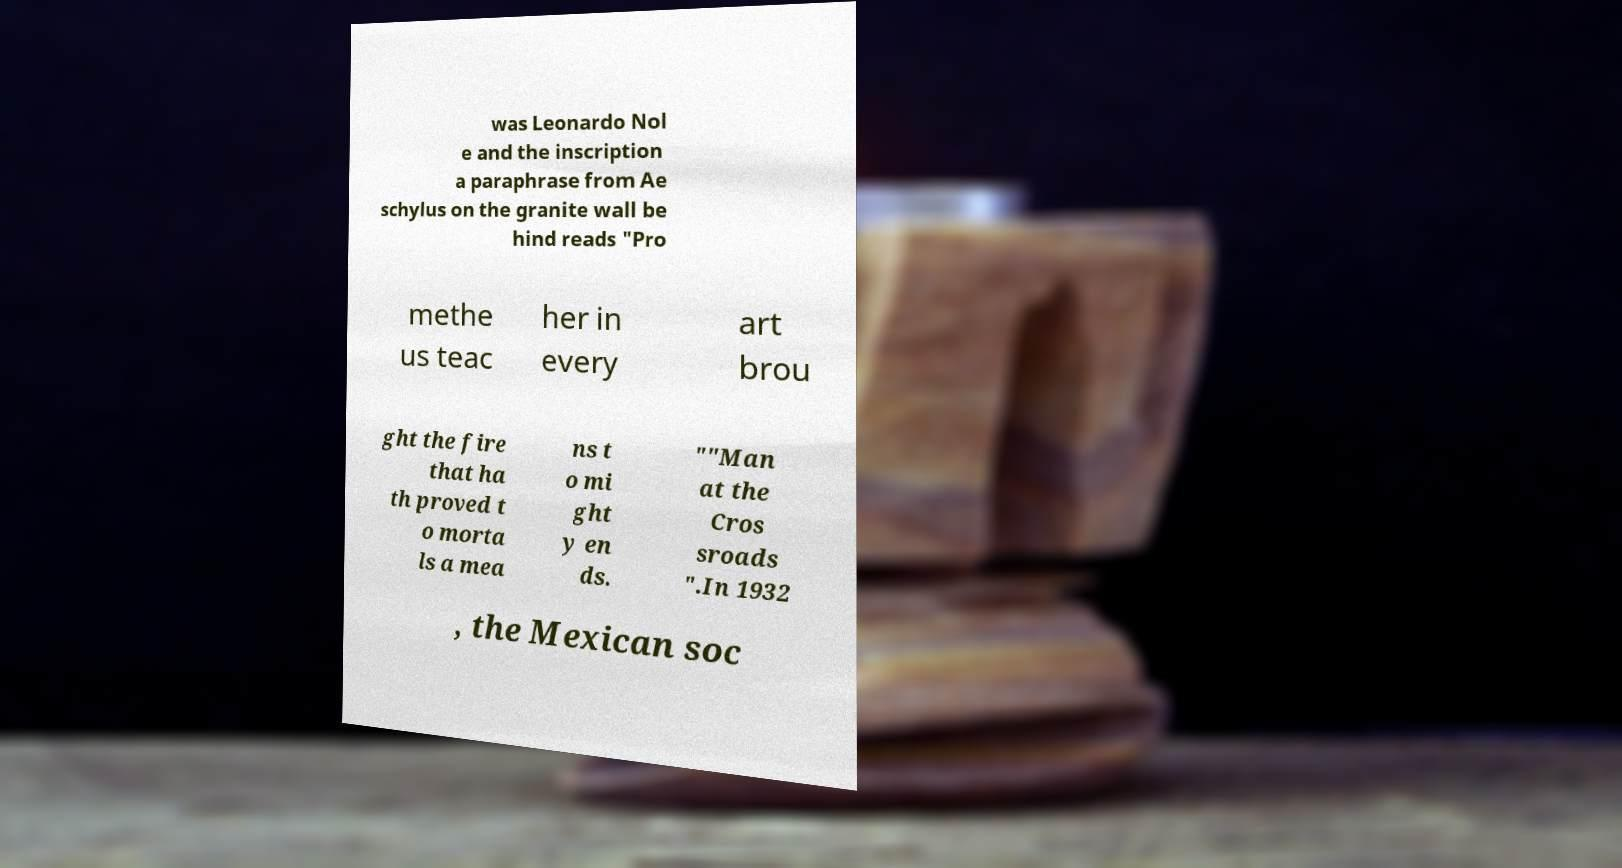Could you extract and type out the text from this image? was Leonardo Nol e and the inscription a paraphrase from Ae schylus on the granite wall be hind reads "Pro methe us teac her in every art brou ght the fire that ha th proved t o morta ls a mea ns t o mi ght y en ds. ""Man at the Cros sroads ".In 1932 , the Mexican soc 